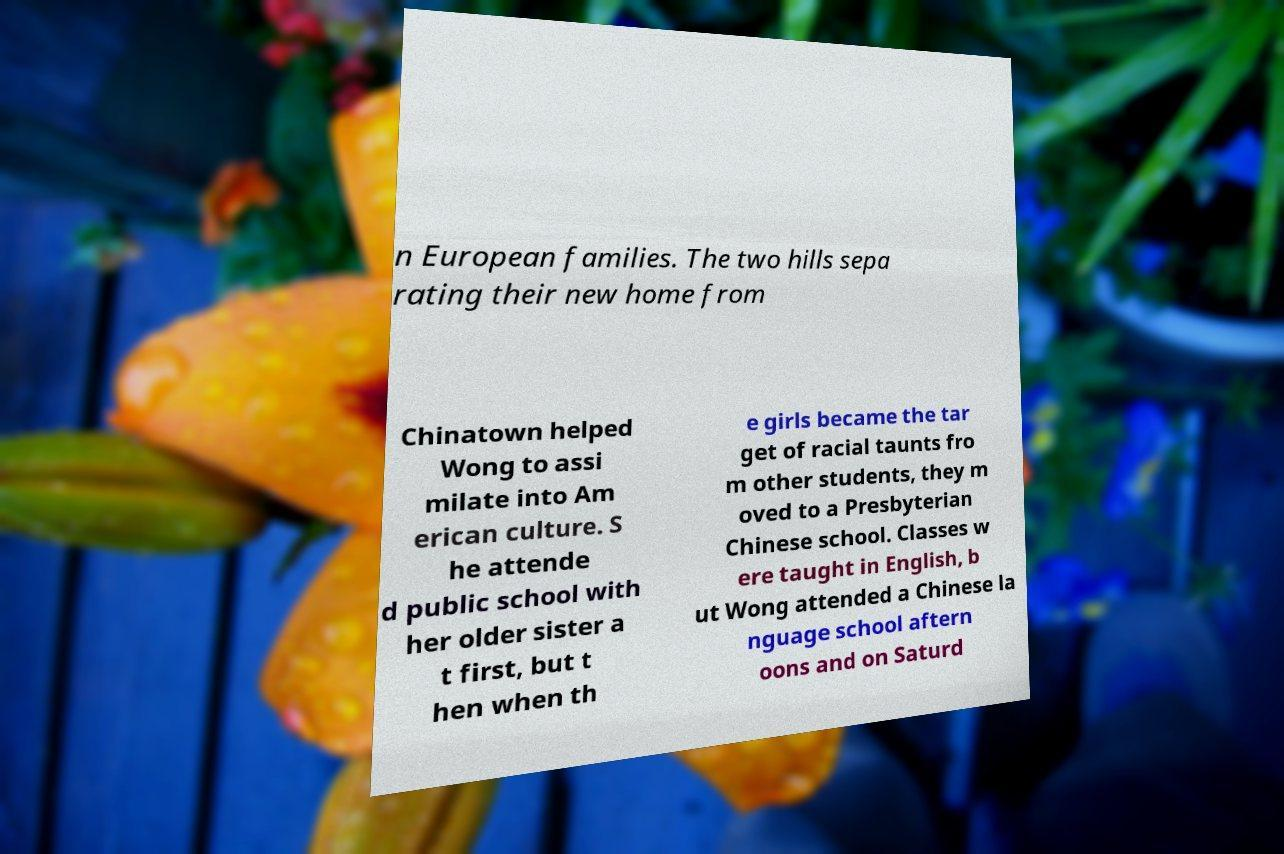Could you assist in decoding the text presented in this image and type it out clearly? n European families. The two hills sepa rating their new home from Chinatown helped Wong to assi milate into Am erican culture. S he attende d public school with her older sister a t first, but t hen when th e girls became the tar get of racial taunts fro m other students, they m oved to a Presbyterian Chinese school. Classes w ere taught in English, b ut Wong attended a Chinese la nguage school aftern oons and on Saturd 